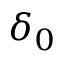Convert formula to latex. <formula><loc_0><loc_0><loc_500><loc_500>\delta _ { 0 }</formula> 